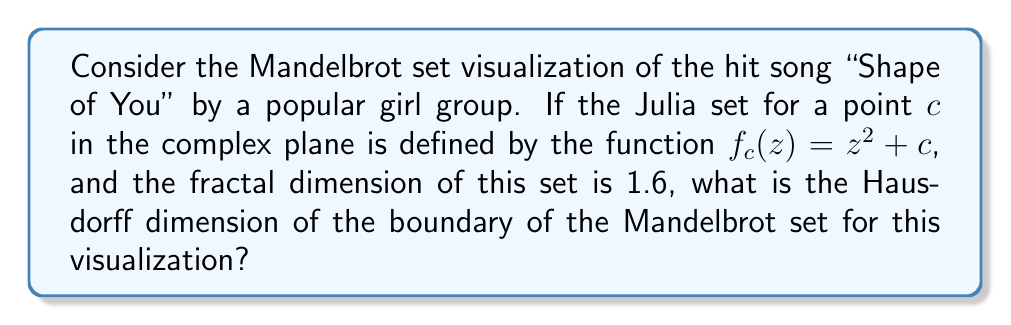Can you answer this question? To solve this problem, we need to follow these steps:

1) Recall that the Mandelbrot set is the set of complex numbers $c$ for which the function $f_c(z) = z^2 + c$ does not diverge when iterated from $z = 0$.

2) The Julia set mentioned in the question is related to the Mandelbrot set, but they are not the same. However, there's a important relationship between their dimensions.

3) The fractal dimension of a Julia set can vary depending on the chosen point $c$, but it's always less than or equal to 2.

4) A key theorem in fractal geometry, proved by Mitsuhiro Shishikura in 1991, states that the Hausdorff dimension of the boundary of the Mandelbrot set is exactly 2.

5) This result is independent of the specific Julia set dimension given (1.6 in this case), as long as the Julia set is a proper fractal (dimension between 1 and 2).

6) Therefore, regardless of the fractal dimension of the specific Julia set mentioned in the question, the Hausdorff dimension of the boundary of the Mandelbrot set remains 2.

This result holds true for any visualization based on the Mandelbrot set, including our hypothetical visualization of "Shape of You".
Answer: 2 